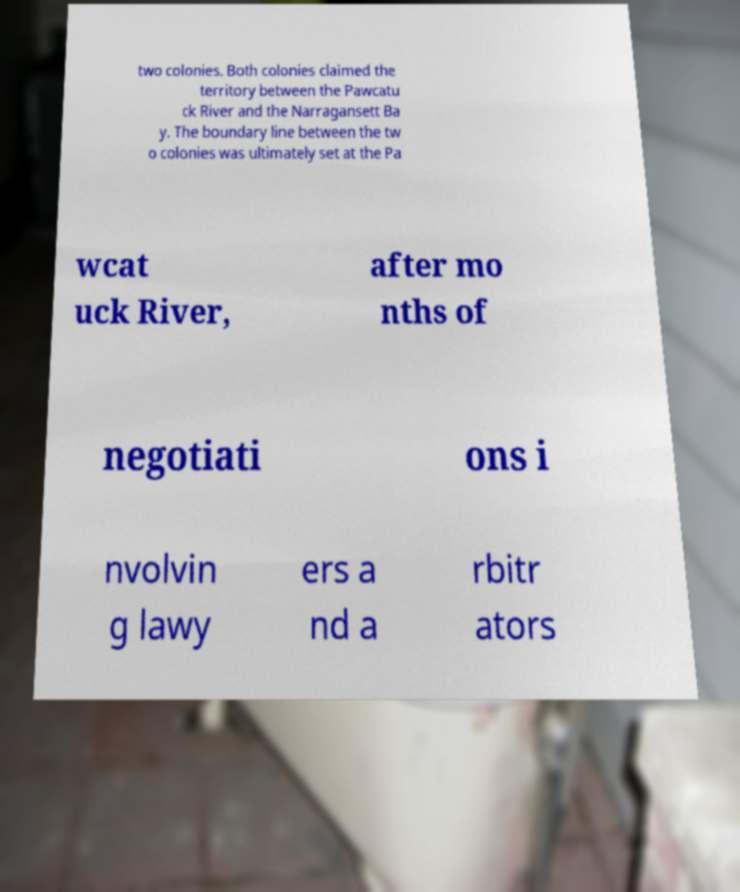I need the written content from this picture converted into text. Can you do that? two colonies. Both colonies claimed the territory between the Pawcatu ck River and the Narragansett Ba y. The boundary line between the tw o colonies was ultimately set at the Pa wcat uck River, after mo nths of negotiati ons i nvolvin g lawy ers a nd a rbitr ators 